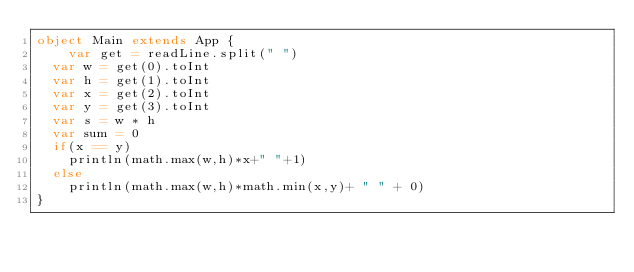<code> <loc_0><loc_0><loc_500><loc_500><_Scala_>object Main extends App {
    var get = readLine.split(" ")
  var w = get(0).toInt
  var h = get(1).toInt
  var x = get(2).toInt
  var y = get(3).toInt
  var s = w * h
  var sum = 0
  if(x == y)
  	println(math.max(w,h)*x+" "+1)
  else
  	println(math.max(w,h)*math.min(x,y)+ " " + 0)
}
  </code> 